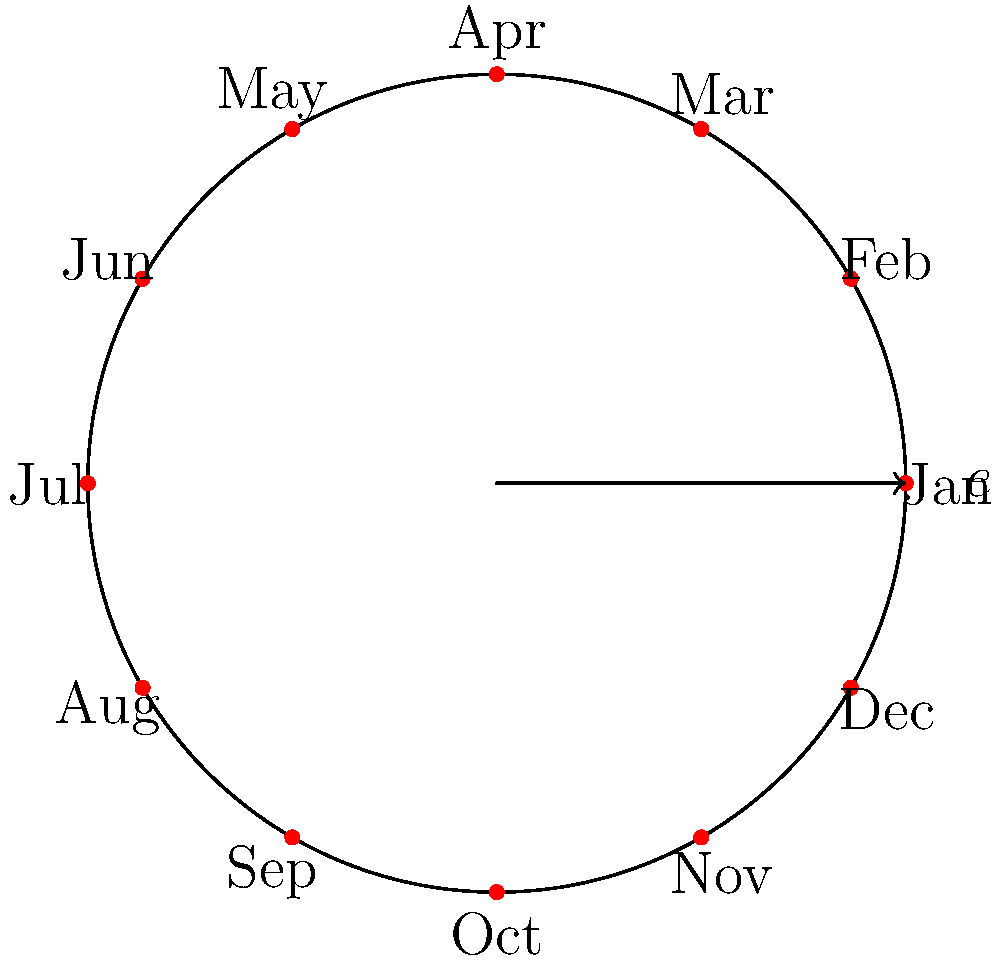In a fantasy world, the calendar system is based on a cyclic group of order 12, representing the 12 months of the year. If we denote the identity element (January) as $e$ and each subsequent month as a power of the generator $g$, what element of the group represents August? To solve this problem, we need to follow these steps:

1. Understand the cyclic group representation:
   - The group has order 12, corresponding to the 12 months.
   - January (the identity element) is represented by $e$ or $g^0$.
   - Each subsequent month is represented by the next power of $g$.

2. Count the months from January to August:
   - January (e) → February ($g^1$) → March ($g^2$) → April ($g^3$) → May ($g^4$) → June ($g^5$) → July ($g^6$) → August

3. Determine the power of $g$ for August:
   - August is the 8th month when counting from January (inclusive).
   - Therefore, August is represented by $g^7$.

4. Verify the result:
   - In a cyclic group of order 12, $g^{12} = e$.
   - $g^7$ is indeed a unique element in this group, as $7 < 12$.

Thus, in this cyclic group representation of the fantasy world's calendar, August is represented by the element $g^7$.
Answer: $g^7$ 